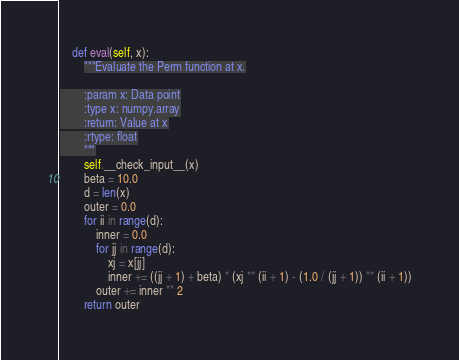<code> <loc_0><loc_0><loc_500><loc_500><_Python_>
    def eval(self, x):
        """Evaluate the Perm function at x.

        :param x: Data point
        :type x: numpy.array
        :return: Value at x
        :rtype: float
        """
        self.__check_input__(x)
        beta = 10.0
        d = len(x)
        outer = 0.0
        for ii in range(d):
            inner = 0.0
            for jj in range(d):
                xj = x[jj]
                inner += ((jj + 1) + beta) * (xj ** (ii + 1) - (1.0 / (jj + 1)) ** (ii + 1))
            outer += inner ** 2
        return outer
</code> 